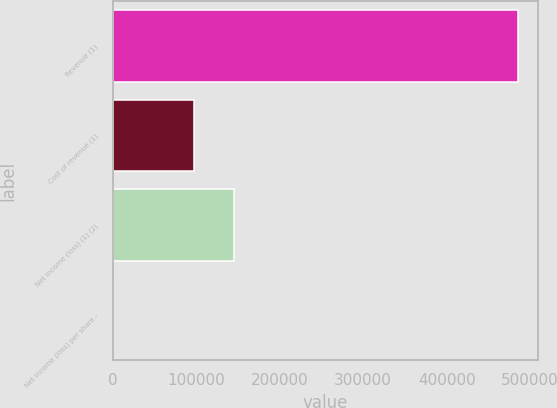<chart> <loc_0><loc_0><loc_500><loc_500><bar_chart><fcel>Revenue (1)<fcel>Cost of revenue (1)<fcel>Net income (loss) (1) (2)<fcel>Net income (loss) per share -<nl><fcel>485398<fcel>97079.8<fcel>145620<fcel>0.29<nl></chart> 